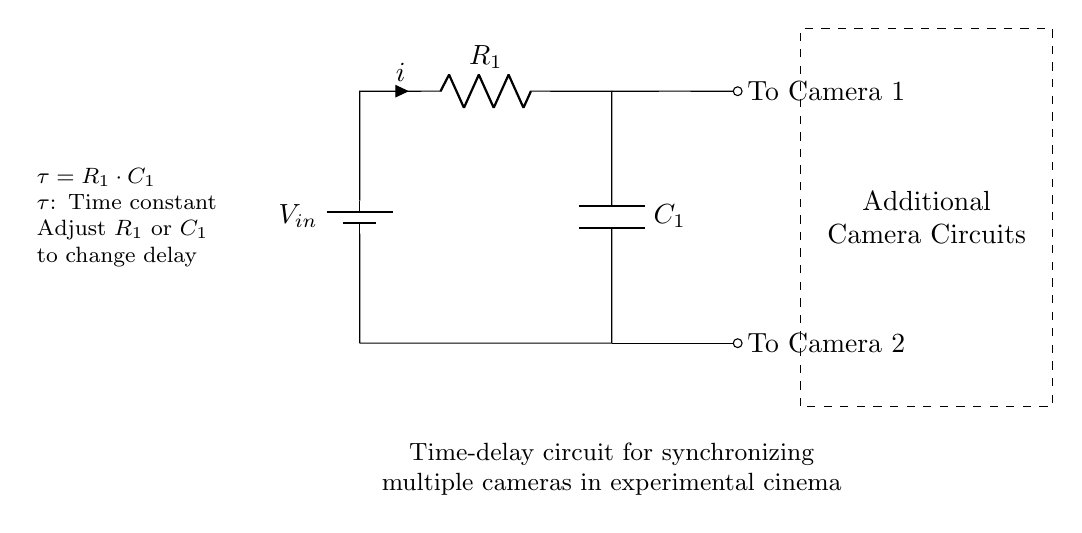What is the input voltage of this circuit? The input voltage is denoted as V_in, which represents the voltage source providing energy to the circuit.
Answer: V_in What components are in this circuit? The circuit consists of a battery (voltage source), a resistor, and a capacitor. These components are shown in the diagram with specific symbols and labels.
Answer: Battery, Resistor, Capacitor What does the dashed box represent? The dashed box indicates additional camera circuits that can be connected to the main time-delay circuit for synchronization purposes in the experimental setup.
Answer: Additional camera circuits What is the formula for the time constant? The time constant τ is given by the formula τ = R_1 · C_1, where R_1 is the resistance and C_1 is the capacitance in the circuit. This relationship dictates how the delay is determined by these two components.
Answer: τ = R_1 · C_1 How can you change the time delay? The time delay can be adjusted by changing either the resistance value R_1 or the capacitance value C_1 that are in the circuit. Increasing these values will increase the delay, while decreasing them will shorten the delay.
Answer: Adjust R_1 or C_1 What does the current direction indicate? The current direction, indicated by the arrow i atop the resistor, shows the flow of electric charge from the voltage source through the resistor and capacitor to the output camera circuits.
Answer: Current i Which cameras are connected to the circuit? The circuit diagram shows connections leading to Camera 1 and Camera 2, indicating that these cameras are synchronized using the time-delay circuit.
Answer: Camera 1 and Camera 2 